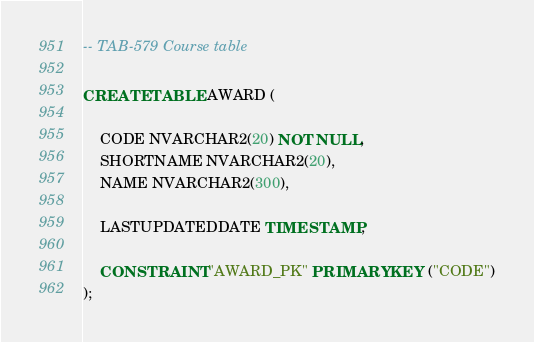Convert code to text. <code><loc_0><loc_0><loc_500><loc_500><_SQL_>-- TAB-579 Course table

CREATE TABLE AWARD (
	
	CODE NVARCHAR2(20) NOT NULL,
	SHORTNAME NVARCHAR2(20),
	NAME NVARCHAR2(300),

  	LASTUPDATEDDATE TIMESTAMP,
  
	CONSTRAINT "AWARD_PK" PRIMARY KEY ("CODE")
);

</code> 